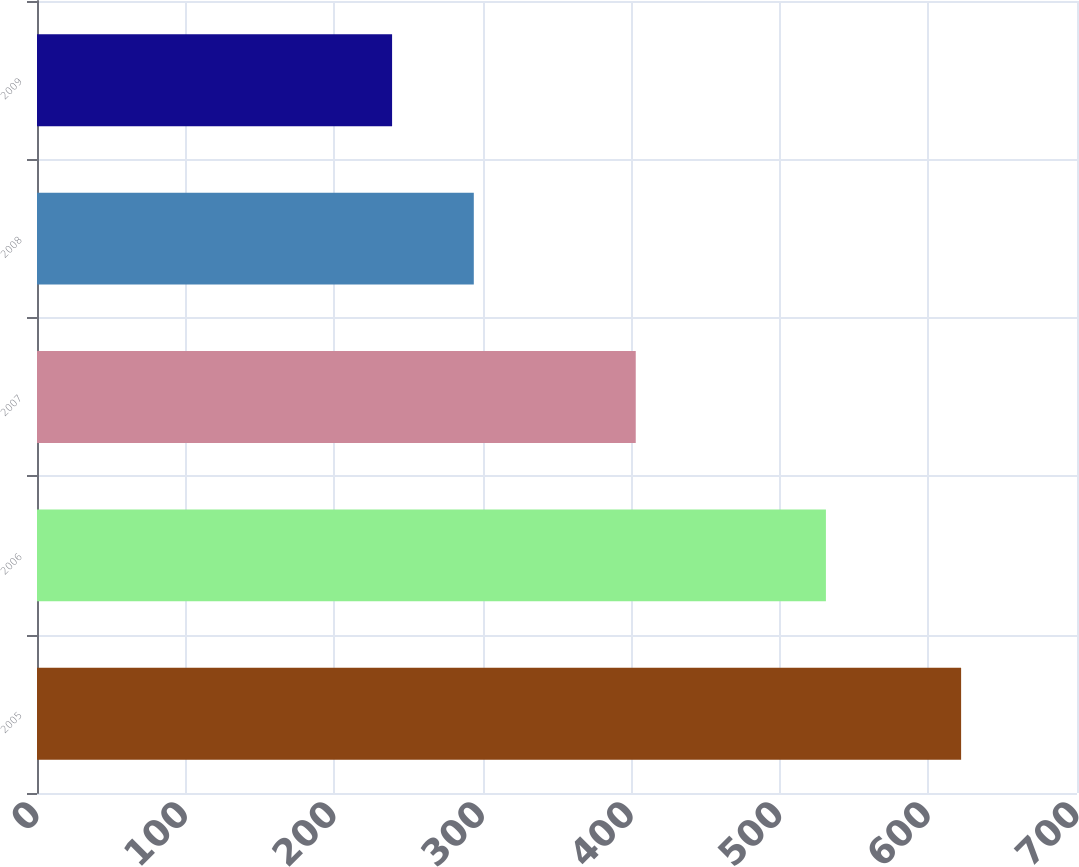<chart> <loc_0><loc_0><loc_500><loc_500><bar_chart><fcel>2005<fcel>2006<fcel>2007<fcel>2008<fcel>2009<nl><fcel>622<fcel>531<fcel>403<fcel>294<fcel>239<nl></chart> 